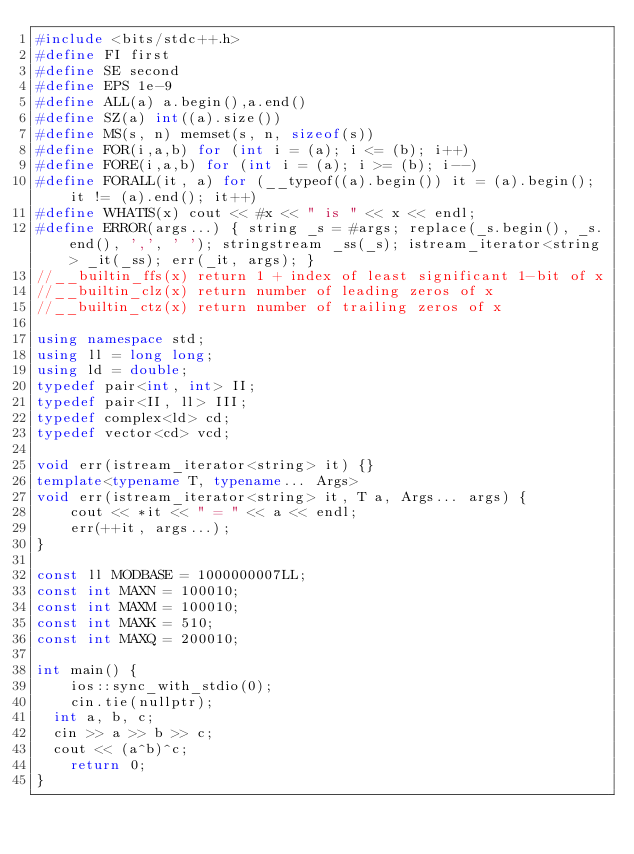Convert code to text. <code><loc_0><loc_0><loc_500><loc_500><_C++_>#include <bits/stdc++.h>
#define FI first
#define SE second
#define EPS 1e-9
#define ALL(a) a.begin(),a.end()
#define SZ(a) int((a).size())
#define MS(s, n) memset(s, n, sizeof(s))
#define FOR(i,a,b) for (int i = (a); i <= (b); i++)
#define FORE(i,a,b) for (int i = (a); i >= (b); i--)
#define FORALL(it, a) for (__typeof((a).begin()) it = (a).begin(); it != (a).end(); it++)
#define WHATIS(x) cout << #x << " is " << x << endl;
#define ERROR(args...) { string _s = #args; replace(_s.begin(), _s.end(), ',', ' '); stringstream _ss(_s); istream_iterator<string> _it(_ss); err(_it, args); }
//__builtin_ffs(x) return 1 + index of least significant 1-bit of x
//__builtin_clz(x) return number of leading zeros of x
//__builtin_ctz(x) return number of trailing zeros of x

using namespace std;
using ll = long long;
using ld = double;
typedef pair<int, int> II;
typedef pair<II, ll> III;
typedef complex<ld> cd;
typedef vector<cd> vcd;

void err(istream_iterator<string> it) {}
template<typename T, typename... Args>
void err(istream_iterator<string> it, T a, Args... args) {
    cout << *it << " = " << a << endl;
    err(++it, args...);
}

const ll MODBASE = 1000000007LL;
const int MAXN = 100010;
const int MAXM = 100010;
const int MAXK = 510;
const int MAXQ = 200010;

int main() {
    ios::sync_with_stdio(0);
    cin.tie(nullptr);
  int a, b, c;
  cin >> a >> b >> c;
  cout << (a^b)^c;
    return 0;
}</code> 